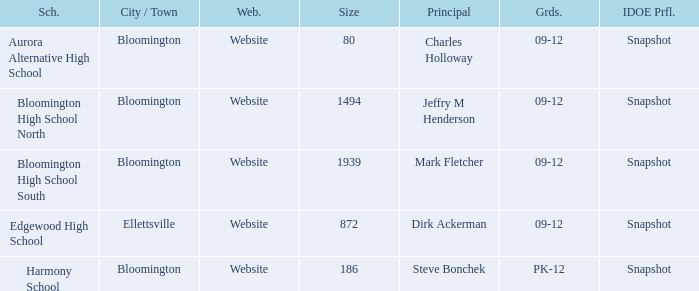Where's the school that Mark Fletcher is the principal of? Bloomington. 